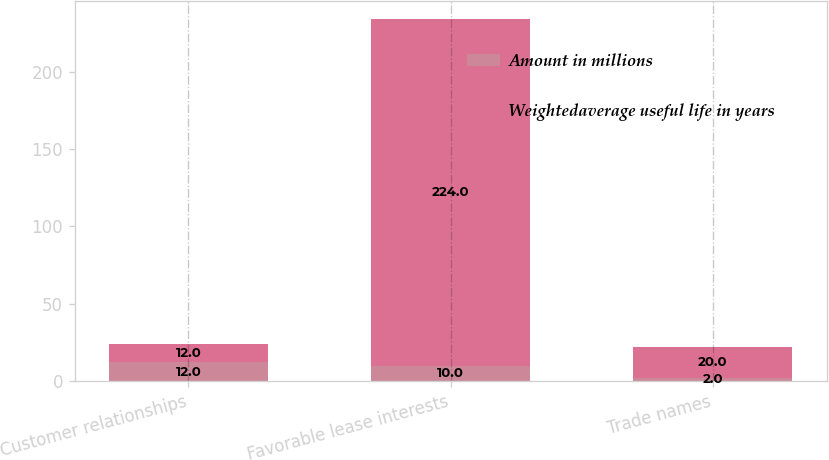<chart> <loc_0><loc_0><loc_500><loc_500><stacked_bar_chart><ecel><fcel>Customer relationships<fcel>Favorable lease interests<fcel>Trade names<nl><fcel>Amount in millions<fcel>12<fcel>10<fcel>2<nl><fcel>Weightedaverage useful life in years<fcel>12<fcel>224<fcel>20<nl></chart> 